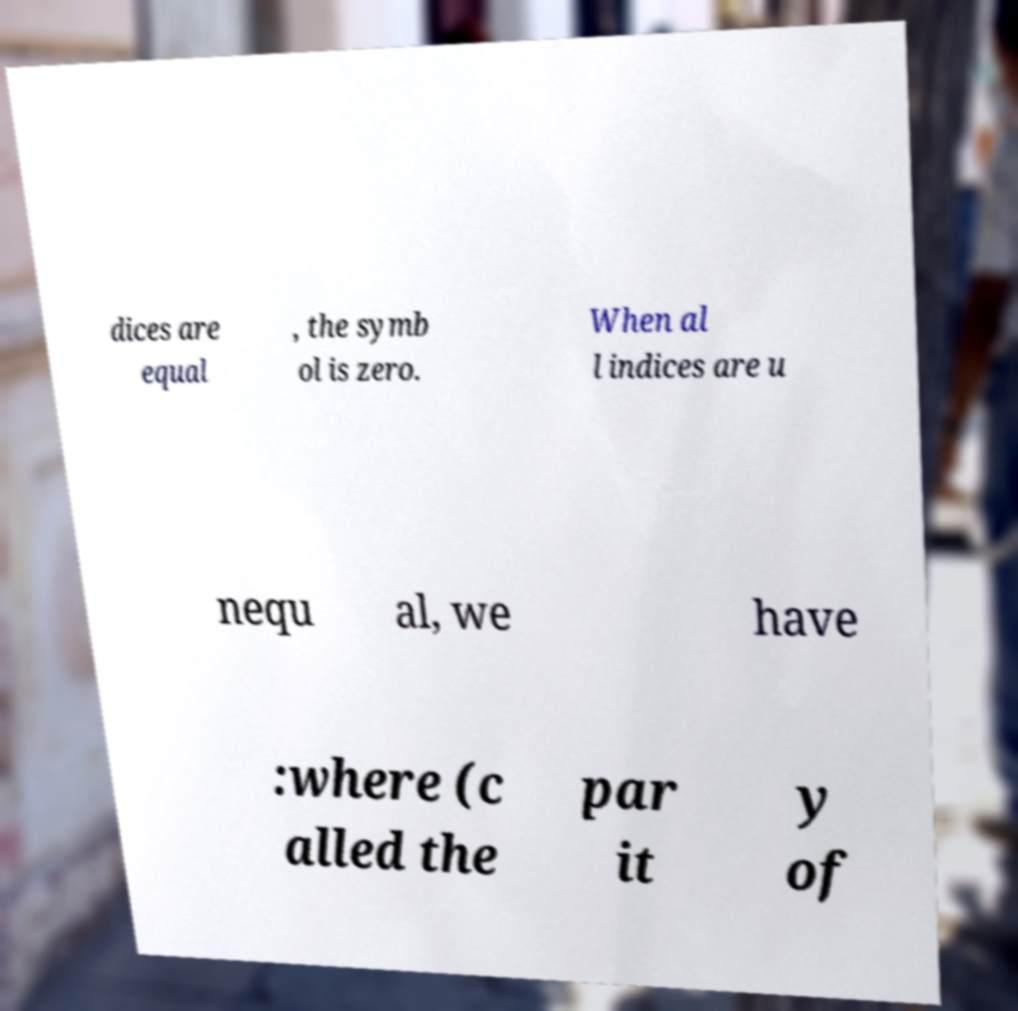There's text embedded in this image that I need extracted. Can you transcribe it verbatim? dices are equal , the symb ol is zero. When al l indices are u nequ al, we have :where (c alled the par it y of 